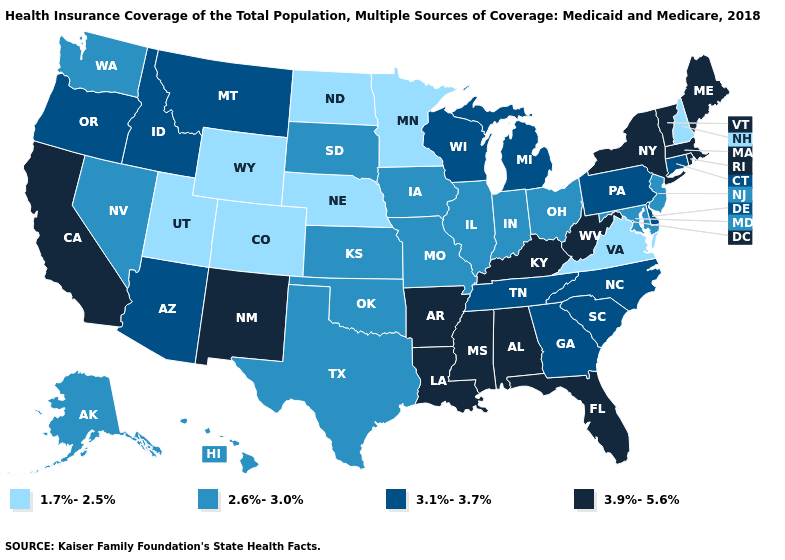What is the value of Massachusetts?
Keep it brief. 3.9%-5.6%. What is the value of New York?
Short answer required. 3.9%-5.6%. Does Vermont have the same value as West Virginia?
Concise answer only. Yes. What is the value of Maine?
Quick response, please. 3.9%-5.6%. Does Indiana have a higher value than Idaho?
Concise answer only. No. What is the highest value in the Northeast ?
Short answer required. 3.9%-5.6%. Name the states that have a value in the range 2.6%-3.0%?
Short answer required. Alaska, Hawaii, Illinois, Indiana, Iowa, Kansas, Maryland, Missouri, Nevada, New Jersey, Ohio, Oklahoma, South Dakota, Texas, Washington. Does Mississippi have the highest value in the South?
Short answer required. Yes. Name the states that have a value in the range 3.9%-5.6%?
Short answer required. Alabama, Arkansas, California, Florida, Kentucky, Louisiana, Maine, Massachusetts, Mississippi, New Mexico, New York, Rhode Island, Vermont, West Virginia. What is the value of Illinois?
Quick response, please. 2.6%-3.0%. What is the value of West Virginia?
Short answer required. 3.9%-5.6%. Does Tennessee have the highest value in the South?
Keep it brief. No. Among the states that border North Dakota , does Minnesota have the highest value?
Quick response, please. No. Name the states that have a value in the range 3.9%-5.6%?
Concise answer only. Alabama, Arkansas, California, Florida, Kentucky, Louisiana, Maine, Massachusetts, Mississippi, New Mexico, New York, Rhode Island, Vermont, West Virginia. 